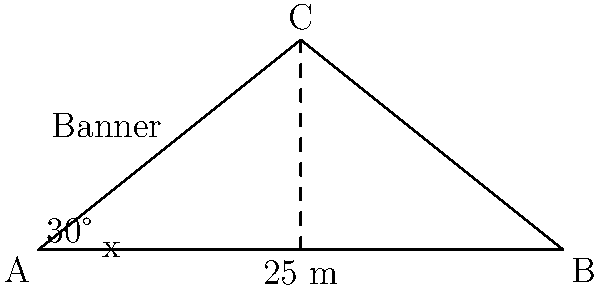As the hotel manager, you're planning to hang a decorative banner across the grand entrance. The banner will span between two poles, forming a triangle with the ground. The distance between the poles is 25 meters, and the angles formed by the banner with the ground are 30° at one end and 60° at the other (as 90° - 30° = 60°). Calculate the length of the banner to the nearest centimeter. Let's approach this step-by-step:

1) First, we need to identify the triangle formed by the banner and the ground. It's a non-right triangle.

2) We can use the law of sines to solve this problem. The law of sines states:

   $$\frac{a}{\sin A} = \frac{b}{\sin B} = \frac{c}{\sin C}$$

   where a, b, and c are the lengths of the sides opposite to angles A, B, and C respectively.

3) In our case:
   - The ground distance (25 m) is opposite to the angle at the top of the triangle.
   - The banner length (what we're solving for) is opposite to the 90° angle.
   - We know two angles: 30° and 60°. The third angle is 90° (remember, angles in a triangle sum to 180°).

4) Let's call the banner length x. Applying the law of sines:

   $$\frac{25}{\sin 90°} = \frac{x}{\sin 30°}$$

5) Simplify, knowing that $\sin 90° = 1$:

   $$25 = \frac{x}{\sin 30°}$$

6) Multiply both sides by $\sin 30°$:

   $$25 \sin 30° = x$$

7) Calculate:
   $$x = 25 * 0.5 = 12.5$$

8) Therefore, the banner length is 12.5 meters or 1250 centimeters.
Answer: 1250 cm 